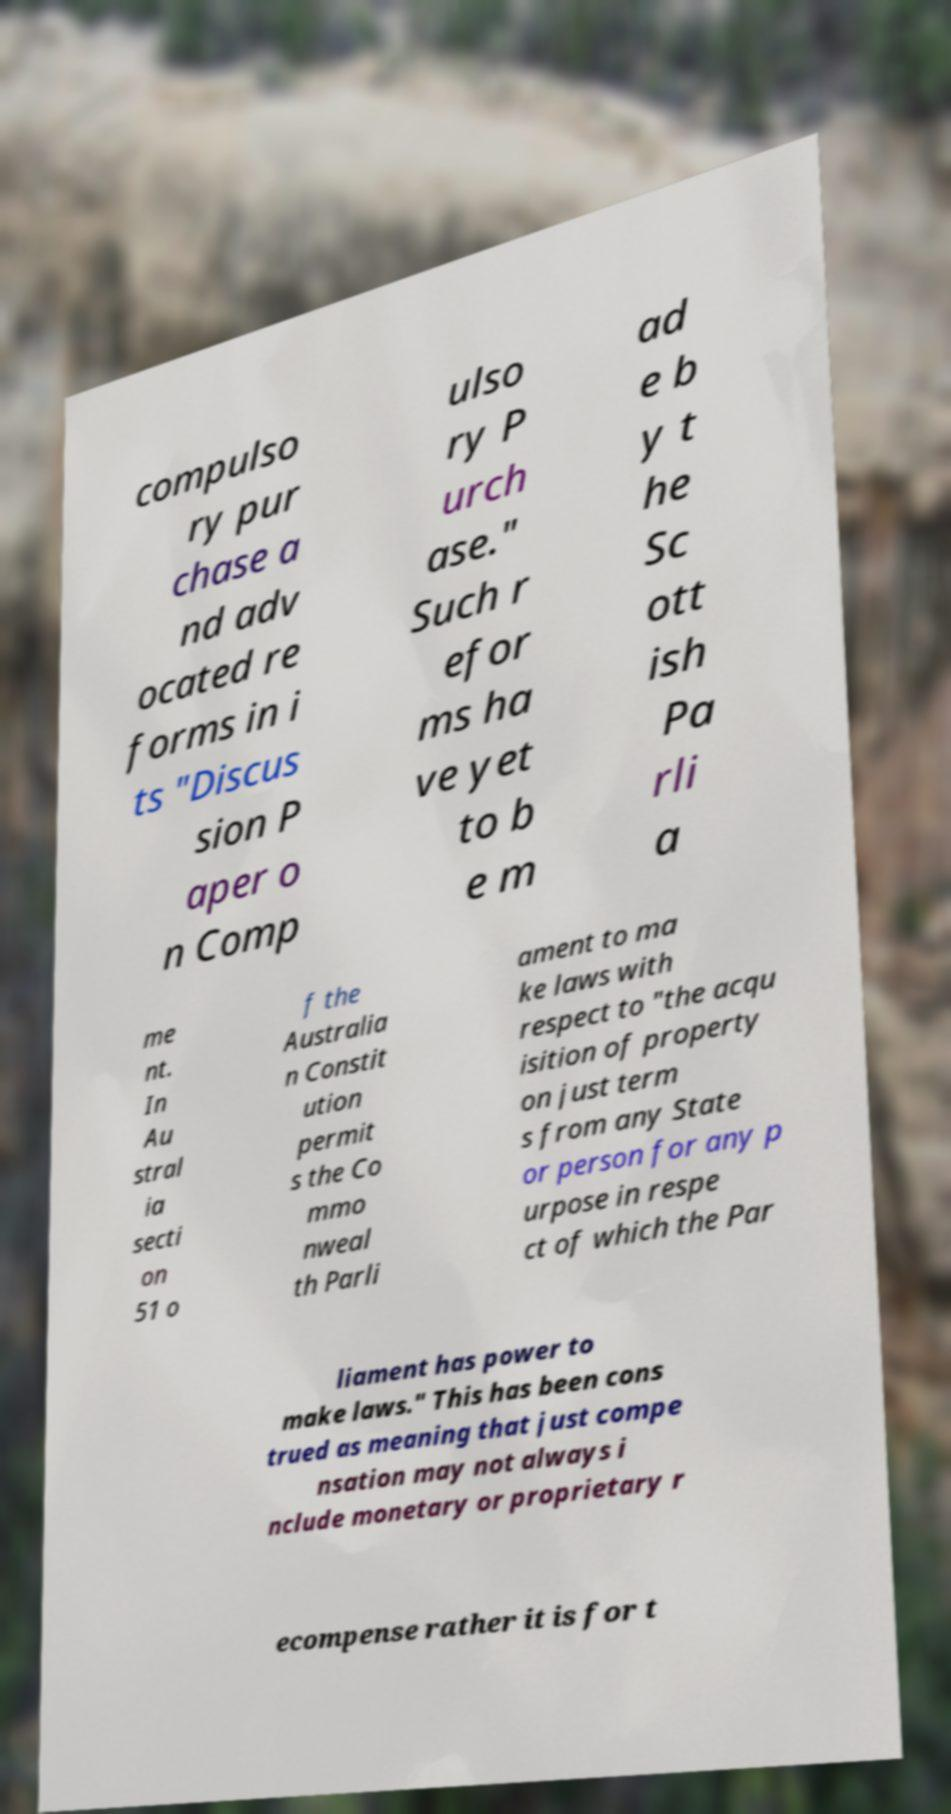For documentation purposes, I need the text within this image transcribed. Could you provide that? compulso ry pur chase a nd adv ocated re forms in i ts "Discus sion P aper o n Comp ulso ry P urch ase." Such r efor ms ha ve yet to b e m ad e b y t he Sc ott ish Pa rli a me nt. In Au stral ia secti on 51 o f the Australia n Constit ution permit s the Co mmo nweal th Parli ament to ma ke laws with respect to "the acqu isition of property on just term s from any State or person for any p urpose in respe ct of which the Par liament has power to make laws." This has been cons trued as meaning that just compe nsation may not always i nclude monetary or proprietary r ecompense rather it is for t 